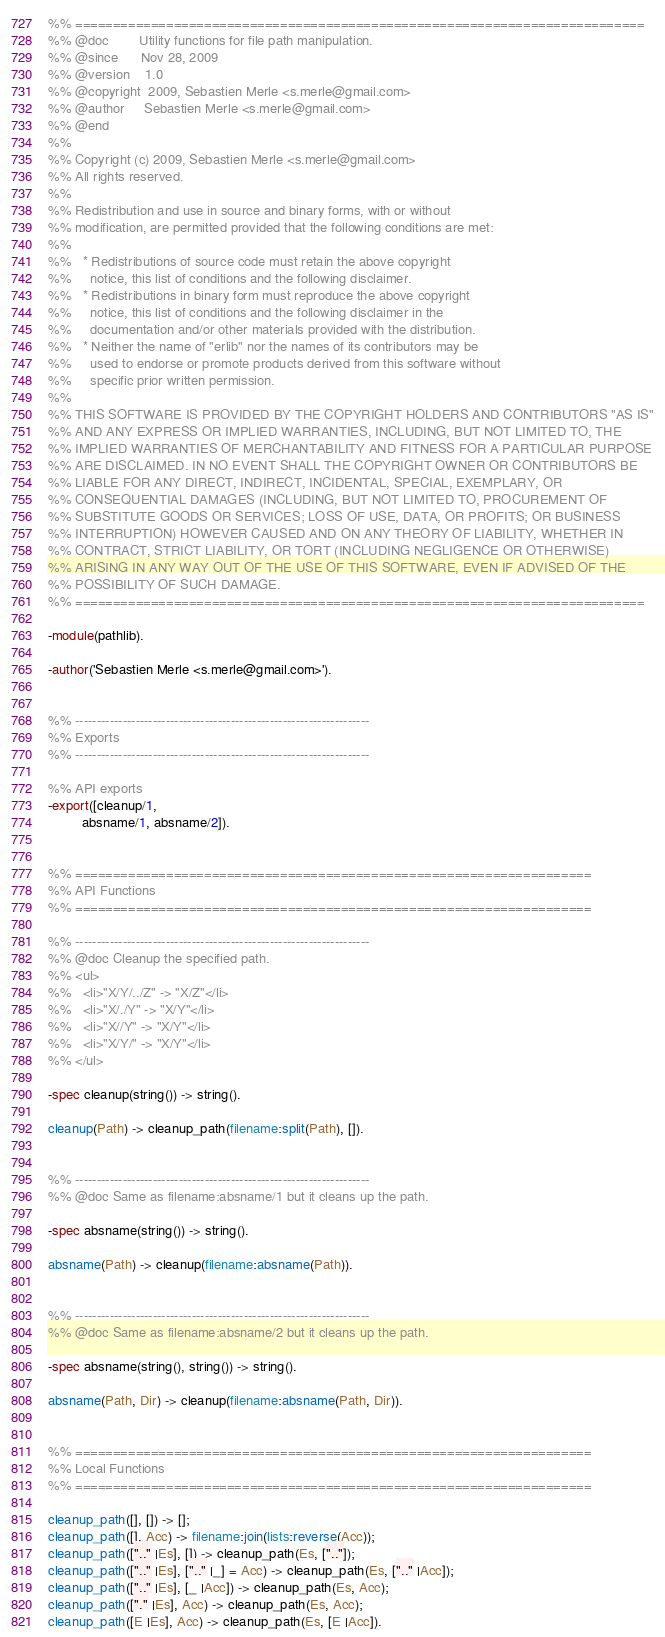Convert code to text. <code><loc_0><loc_0><loc_500><loc_500><_Erlang_>%% ===========================================================================
%% @doc        Utility functions for file path manipulation.
%% @since      Nov 28, 2009
%% @version    1.0
%% @copyright  2009, Sebastien Merle <s.merle@gmail.com>
%% @author     Sebastien Merle <s.merle@gmail.com>
%% @end
%%
%% Copyright (c) 2009, Sebastien Merle <s.merle@gmail.com>
%% All rights reserved.
%%
%% Redistribution and use in source and binary forms, with or without
%% modification, are permitted provided that the following conditions are met:
%%
%%   * Redistributions of source code must retain the above copyright
%%     notice, this list of conditions and the following disclaimer.
%%   * Redistributions in binary form must reproduce the above copyright
%%     notice, this list of conditions and the following disclaimer in the
%%     documentation and/or other materials provided with the distribution.
%%   * Neither the name of "erlib" nor the names of its contributors may be
%%     used to endorse or promote products derived from this software without
%%     specific prior written permission.
%%
%% THIS SOFTWARE IS PROVIDED BY THE COPYRIGHT HOLDERS AND CONTRIBUTORS "AS IS"
%% AND ANY EXPRESS OR IMPLIED WARRANTIES, INCLUDING, BUT NOT LIMITED TO, THE
%% IMPLIED WARRANTIES OF MERCHANTABILITY AND FITNESS FOR A PARTICULAR PURPOSE
%% ARE DISCLAIMED. IN NO EVENT SHALL THE COPYRIGHT OWNER OR CONTRIBUTORS BE
%% LIABLE FOR ANY DIRECT, INDIRECT, INCIDENTAL, SPECIAL, EXEMPLARY, OR
%% CONSEQUENTIAL DAMAGES (INCLUDING, BUT NOT LIMITED TO, PROCUREMENT OF
%% SUBSTITUTE GOODS OR SERVICES; LOSS OF USE, DATA, OR PROFITS; OR BUSINESS
%% INTERRUPTION) HOWEVER CAUSED AND ON ANY THEORY OF LIABILITY, WHETHER IN
%% CONTRACT, STRICT LIABILITY, OR TORT (INCLUDING NEGLIGENCE OR OTHERWISE)
%% ARISING IN ANY WAY OUT OF THE USE OF THIS SOFTWARE, EVEN IF ADVISED OF THE
%% POSSIBILITY OF SUCH DAMAGE.
%% ===========================================================================

-module(pathlib).

-author('Sebastien Merle <s.merle@gmail.com>').


%% --------------------------------------------------------------------
%% Exports
%% --------------------------------------------------------------------

%% API exports
-export([cleanup/1,
         absname/1, absname/2]).


%% ====================================================================
%% API Functions
%% ====================================================================

%% --------------------------------------------------------------------
%% @doc Cleanup the specified path.
%% <ul> 
%%   <li>"X/Y/../Z" -> "X/Z"</li>
%%   <li>"X/./Y" -> "X/Y"</li>
%%   <li>"X//Y" -> "X/Y"</li>
%%   <li>"X/Y/" -> "X/Y"</li>
%% </ul>

-spec cleanup(string()) -> string().

cleanup(Path) -> cleanup_path(filename:split(Path), []).


%% --------------------------------------------------------------------
%% @doc Same as filename:absname/1 but it cleans up the path.

-spec absname(string()) -> string().

absname(Path) -> cleanup(filename:absname(Path)).


%% --------------------------------------------------------------------
%% @doc Same as filename:absname/2 but it cleans up the path.

-spec absname(string(), string()) -> string().

absname(Path, Dir) -> cleanup(filename:absname(Path, Dir)).


%% ====================================================================
%% Local Functions
%% ====================================================================

cleanup_path([], []) -> [];
cleanup_path([], Acc) -> filename:join(lists:reverse(Acc));
cleanup_path([".." |Es], []) -> cleanup_path(Es, [".."]);
cleanup_path([".." |Es], [".." |_] = Acc) -> cleanup_path(Es, [".." |Acc]);
cleanup_path([".." |Es], [_ |Acc]) -> cleanup_path(Es, Acc);
cleanup_path(["." |Es], Acc) -> cleanup_path(Es, Acc);
cleanup_path([E |Es], Acc) -> cleanup_path(Es, [E |Acc]).
</code> 